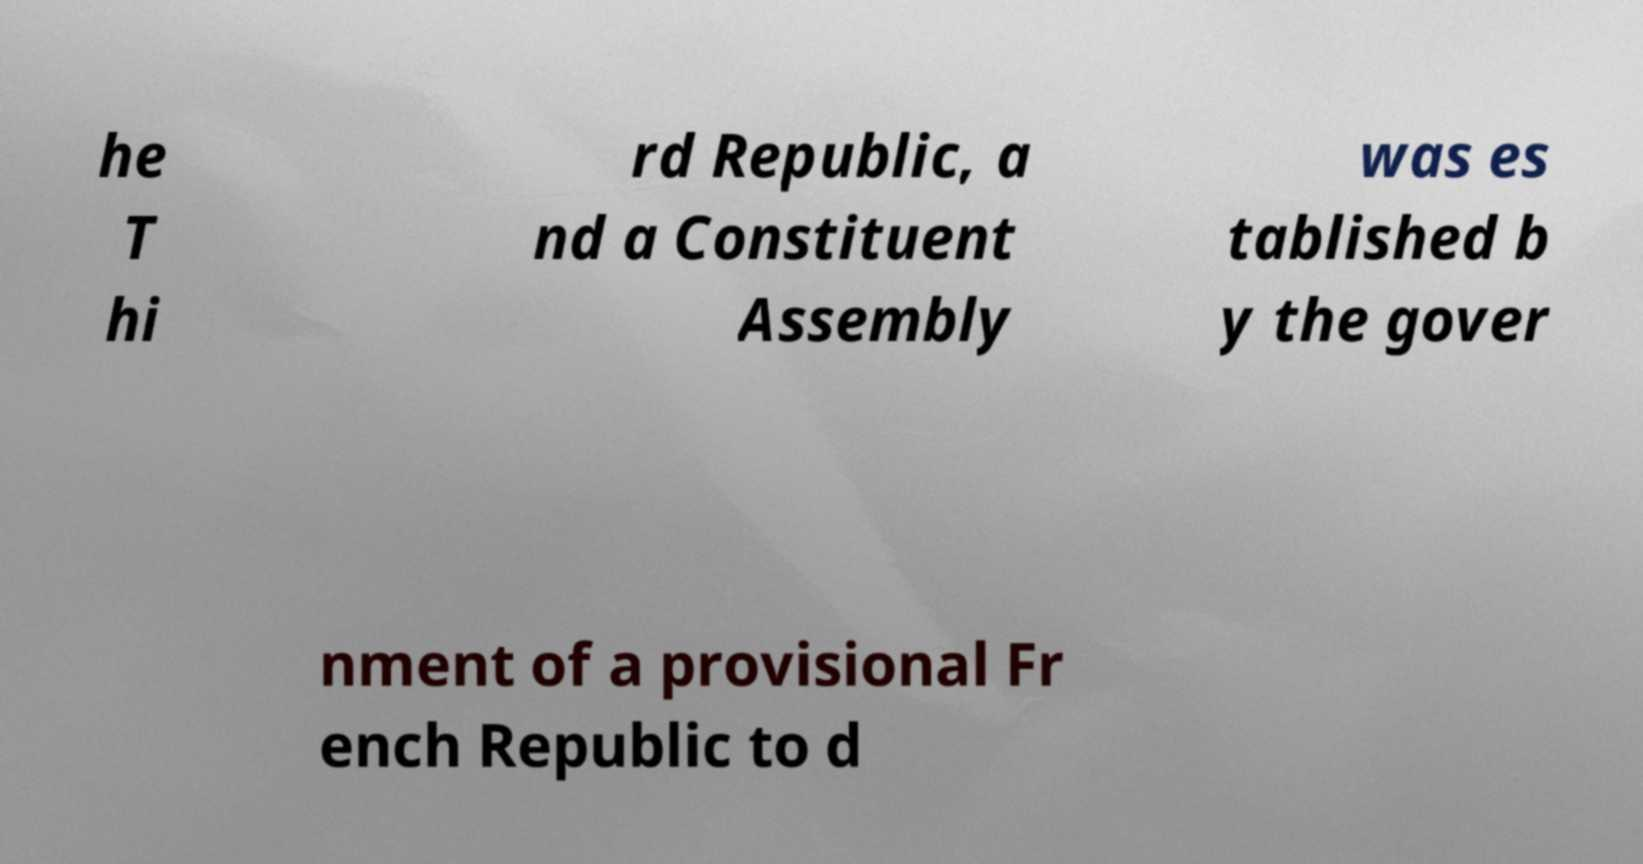There's text embedded in this image that I need extracted. Can you transcribe it verbatim? he T hi rd Republic, a nd a Constituent Assembly was es tablished b y the gover nment of a provisional Fr ench Republic to d 